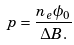Convert formula to latex. <formula><loc_0><loc_0><loc_500><loc_500>p = \frac { n _ { e } \phi _ { 0 } } { \Delta B . }</formula> 